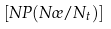Convert formula to latex. <formula><loc_0><loc_0><loc_500><loc_500>\left [ N P ( N \sigma / N _ { t } ) \right ]</formula> 